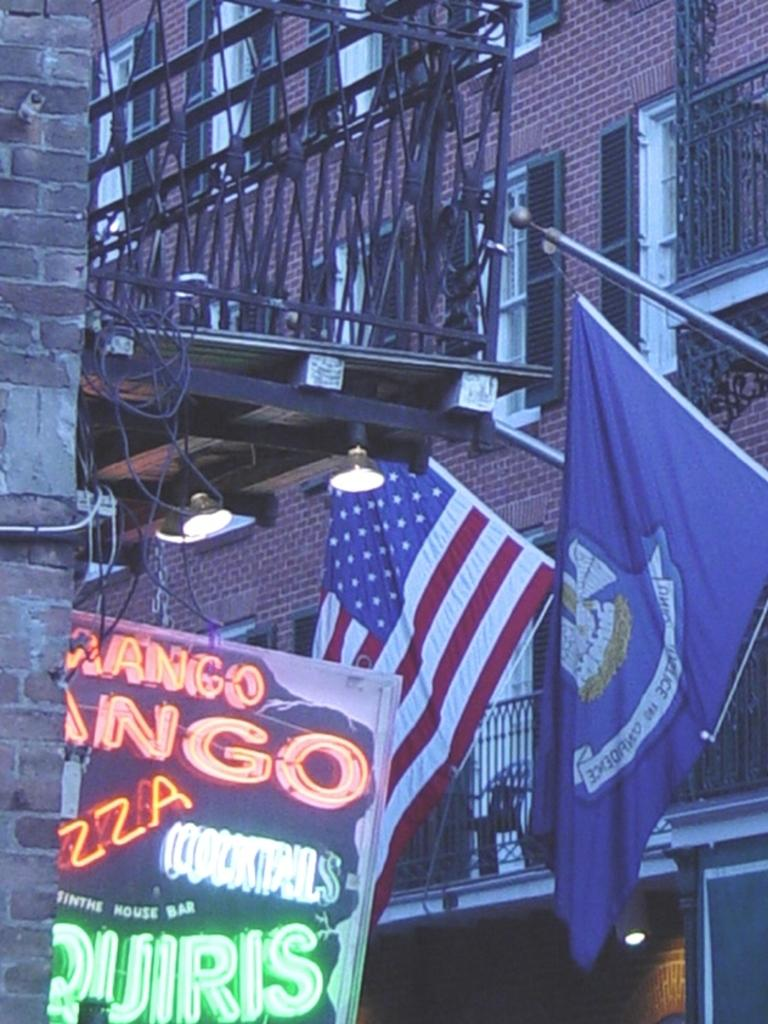What type of structure can be seen in the image? There is a building with windows in the image. What architectural feature is present in the image? There are railings in the image. What type of wall is visible in the image? There is a brick wall in the image. What are the flags attached to in the image? The flags are attached to rods in the image. What additional signage is present in the image? There is a banner in the image. What type of lighting is visible in the image? There are lights in the image. What type of brush is being used to paint the expansion in the image? There is no expansion or painting activity present in the image. What is the tongue doing in the image? There is no tongue present in the image. 